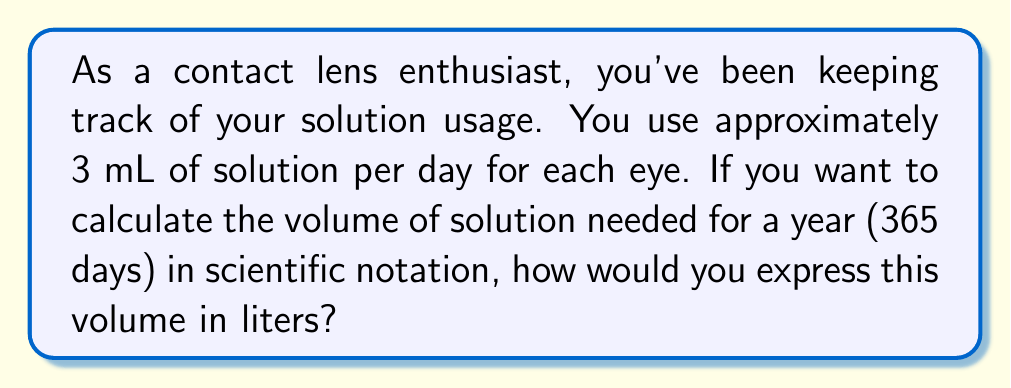Can you solve this math problem? To solve this problem, let's break it down into steps:

1. Calculate the daily usage:
   $3 \text{ mL per eye} \times 2 \text{ eyes} = 6 \text{ mL per day}$

2. Calculate the yearly usage in mL:
   $6 \text{ mL per day} \times 365 \text{ days} = 2190 \text{ mL per year}$

3. Convert mL to L:
   $2190 \text{ mL} = 2.190 \text{ L}$

4. Express in scientific notation:
   $2.190 \text{ L} = 2.190 \times 10^0 \text{ L}$

To properly express this in scientific notation, we need to move the decimal point one place to the right:

$2.190 \times 10^0 \text{ L} = 2.190 \times 10^0 \text{ L} = 2.190 \times 10^0 \text{ L}$

Therefore, the volume of contact lens solution needed for a year, expressed in scientific notation, is $2.190 \times 10^0 \text{ L}$.
Answer: $2.190 \times 10^0 \text{ L}$ 